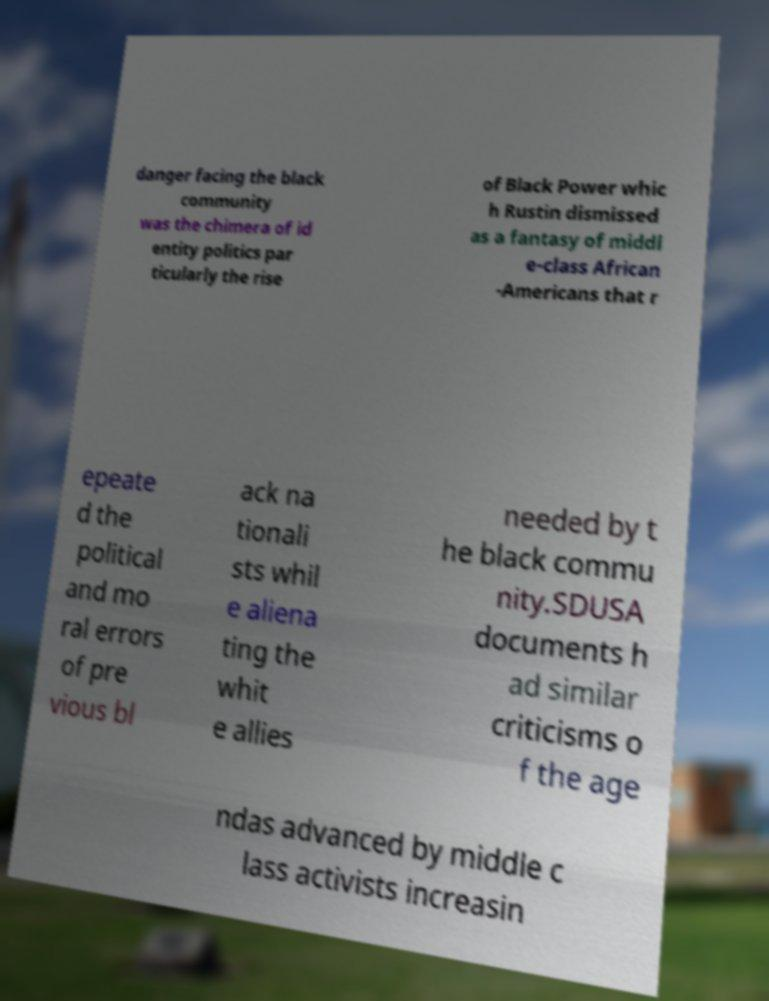Can you read and provide the text displayed in the image?This photo seems to have some interesting text. Can you extract and type it out for me? danger facing the black community was the chimera of id entity politics par ticularly the rise of Black Power whic h Rustin dismissed as a fantasy of middl e-class African -Americans that r epeate d the political and mo ral errors of pre vious bl ack na tionali sts whil e aliena ting the whit e allies needed by t he black commu nity.SDUSA documents h ad similar criticisms o f the age ndas advanced by middle c lass activists increasin 